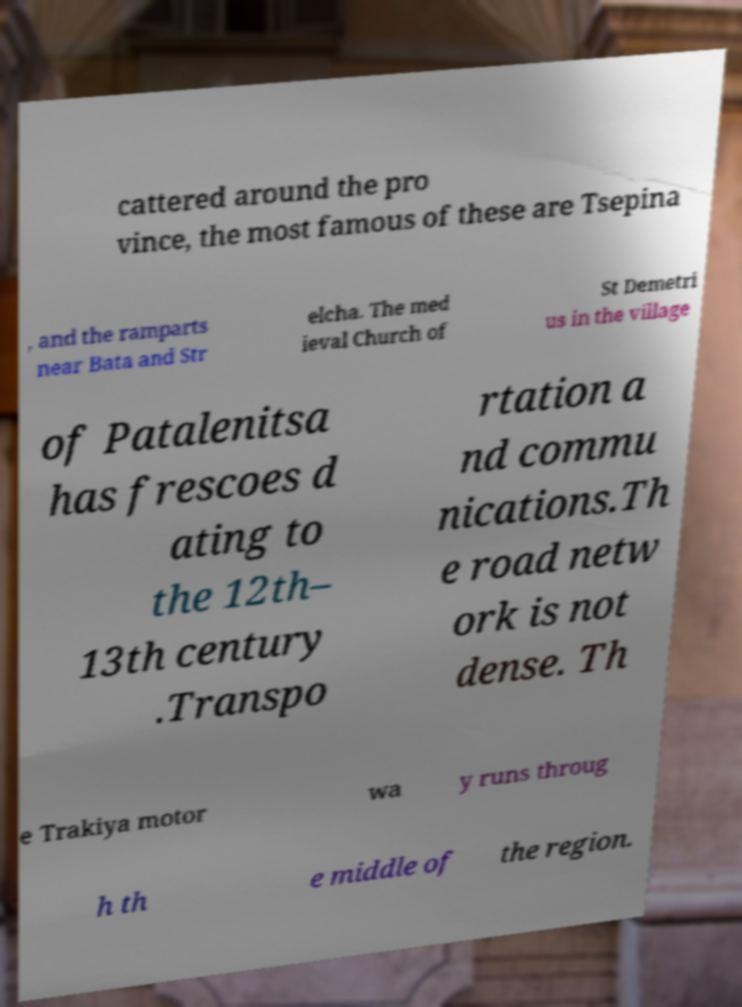I need the written content from this picture converted into text. Can you do that? cattered around the pro vince, the most famous of these are Tsepina , and the ramparts near Bata and Str elcha. The med ieval Church of St Demetri us in the village of Patalenitsa has frescoes d ating to the 12th– 13th century .Transpo rtation a nd commu nications.Th e road netw ork is not dense. Th e Trakiya motor wa y runs throug h th e middle of the region. 